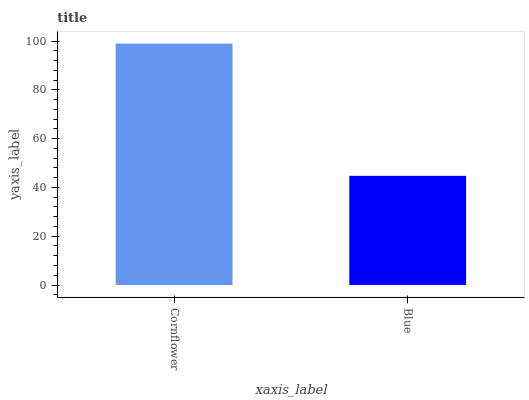Is Blue the maximum?
Answer yes or no. No. Is Cornflower greater than Blue?
Answer yes or no. Yes. Is Blue less than Cornflower?
Answer yes or no. Yes. Is Blue greater than Cornflower?
Answer yes or no. No. Is Cornflower less than Blue?
Answer yes or no. No. Is Cornflower the high median?
Answer yes or no. Yes. Is Blue the low median?
Answer yes or no. Yes. Is Blue the high median?
Answer yes or no. No. Is Cornflower the low median?
Answer yes or no. No. 